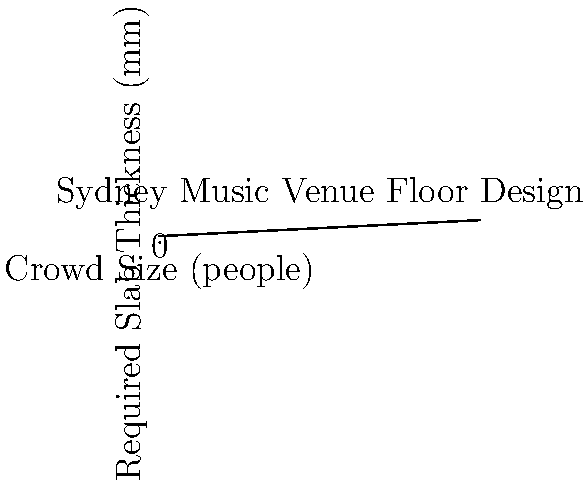As a music enthusiast planning a new electronic music venue in Sydney, you need to estimate the required thickness of the concrete slab floor. Given the graph showing the relationship between crowd size and slab thickness, what would be the approximate required thickness (in mm) for a venue expecting a maximum crowd of 3000 people? To solve this problem, we'll follow these steps:

1. Understand the graph:
   - The x-axis represents the crowd size in people
   - The y-axis represents the required slab thickness in mm
   - The line shows the relationship between these two variables

2. Locate the point on the x-axis:
   - We're interested in a crowd size of 3000 people

3. Find the corresponding y-value:
   - Trace a vertical line from 3000 on the x-axis up to the graph line
   - From that point, trace a horizontal line to the y-axis

4. Read the approximate thickness:
   - The y-value corresponding to 3000 people is about 250 mm

5. Verify the result:
   - We can see that the line follows the equation: $y = 100 + 0.05x$
   - Where $y$ is the thickness in mm and $x$ is the crowd size
   - Plugging in 3000 for $x$:
     $y = 100 + 0.05(3000) = 100 + 150 = 250$ mm

Therefore, the required thickness of the concrete slab floor for a venue expecting a maximum crowd of 3000 people would be approximately 250 mm.
Answer: 250 mm 